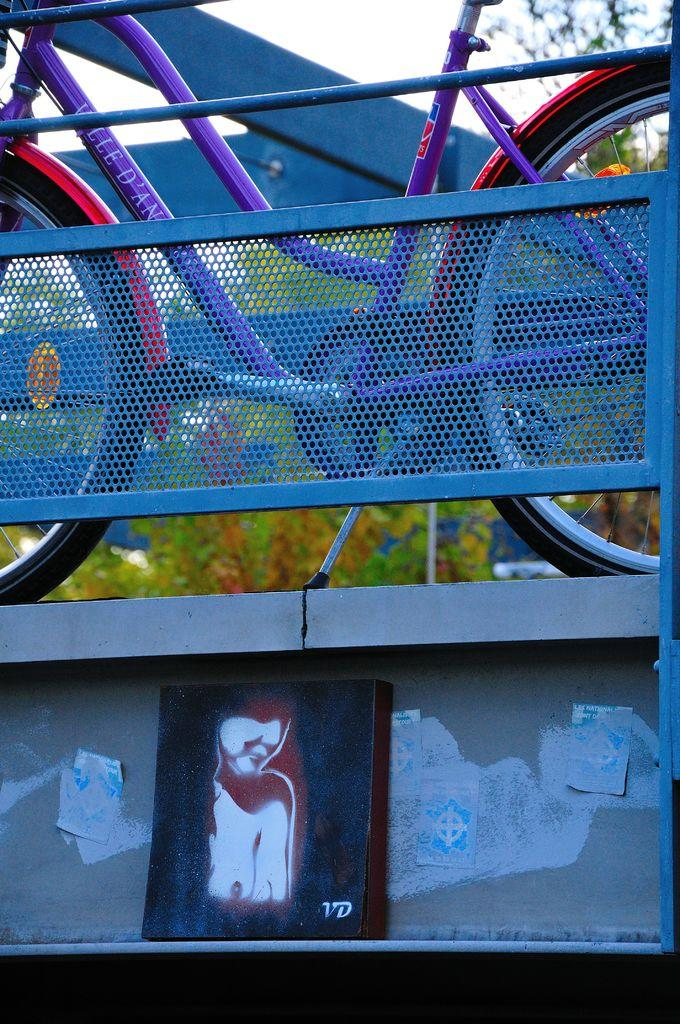What is located in the middle of the image? There is a fencing in the middle of the image. What can be seen behind the fencing? There is a bicycle behind the fencing. What type of vegetation is visible behind the bicycle? There are trees behind the bicycle. What is visible at the top of the image? The sky is visible at the top of the image. What sound can be heard coming from the elbow in the image? There is no elbow present in the image, and therefore no sound can be heard from it. 